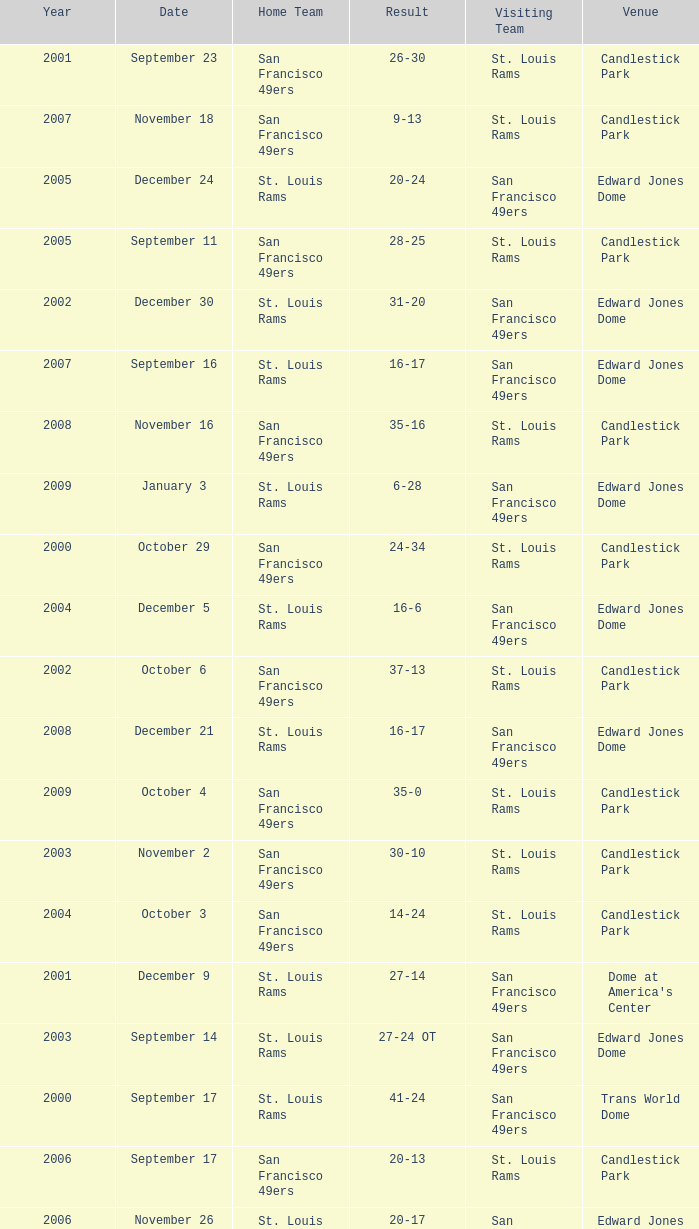What Date after 2007 had the San Francisco 49ers as the Visiting Team? December 21, January 3. 